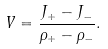<formula> <loc_0><loc_0><loc_500><loc_500>V = \frac { J _ { + } - J _ { - } } { \rho _ { + } - \rho _ { - } } .</formula> 